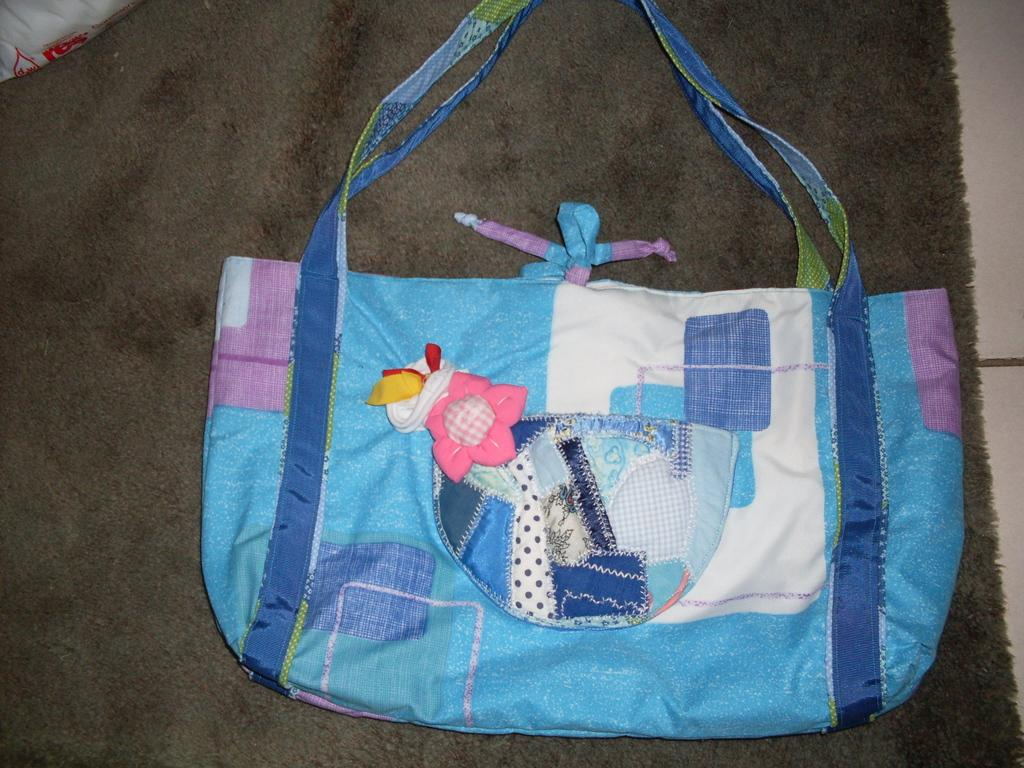What object can be seen in the image? There is a handbag in the image. What color is the handbag? The handbag is blue in color. How many jellyfish are swimming in the handbag in the image? There are no jellyfish present in the image, as it features a handbag and not an underwater scene. 